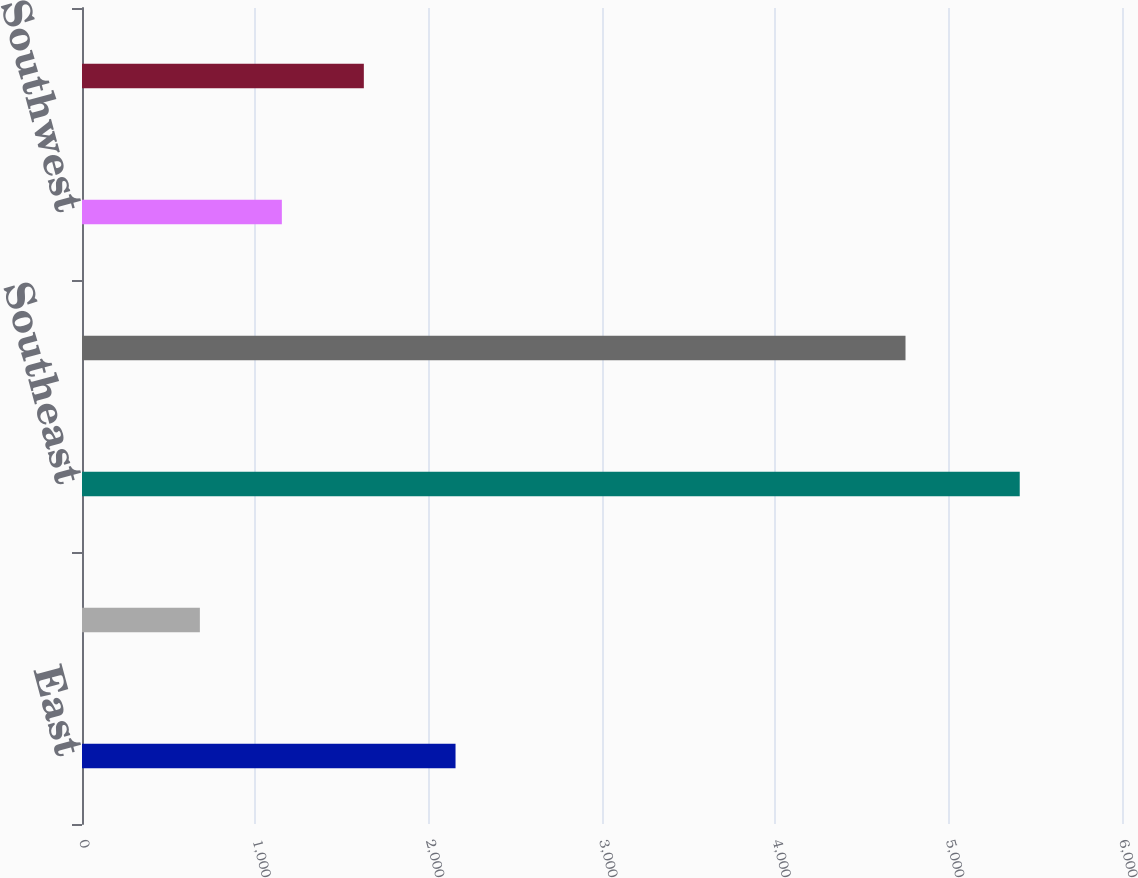Convert chart to OTSL. <chart><loc_0><loc_0><loc_500><loc_500><bar_chart><fcel>East<fcel>Midwest<fcel>Southeast<fcel>South Central<fcel>Southwest<fcel>West<nl><fcel>2155<fcel>680<fcel>5410<fcel>4751<fcel>1153<fcel>1626<nl></chart> 